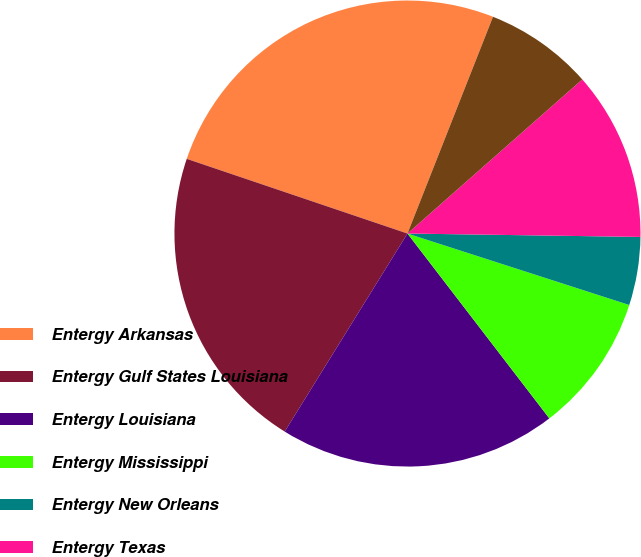Convert chart to OTSL. <chart><loc_0><loc_0><loc_500><loc_500><pie_chart><fcel>Entergy Arkansas<fcel>Entergy Gulf States Louisiana<fcel>Entergy Louisiana<fcel>Entergy Mississippi<fcel>Entergy New Orleans<fcel>Entergy Texas<fcel>System Energy<nl><fcel>25.79%<fcel>21.36%<fcel>19.25%<fcel>9.62%<fcel>4.73%<fcel>11.73%<fcel>7.52%<nl></chart> 